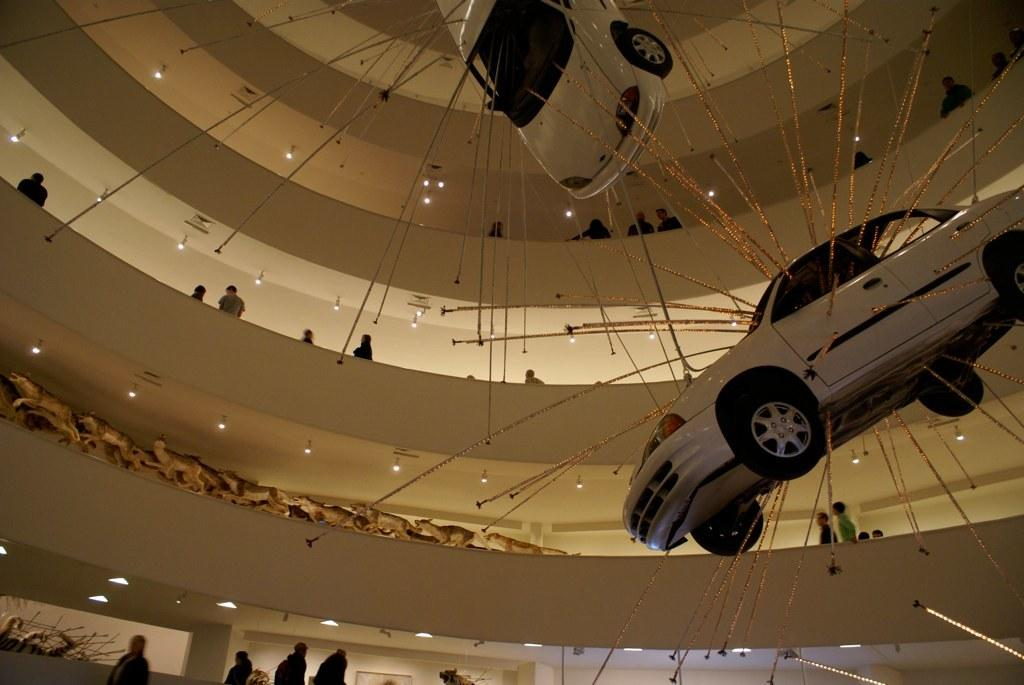How many cars are present in the image? There are two cars in the image. Can you describe the people in the image? There are people in the image, but their specific actions or characteristics are not mentioned in the facts. What type of structure is visible in the image? There is a building in the image. What can be seen illuminated in the image? There are lights visible in the image. How many apples are being observed by the people in the image? There is no mention of apples or any observation activity in the image. 